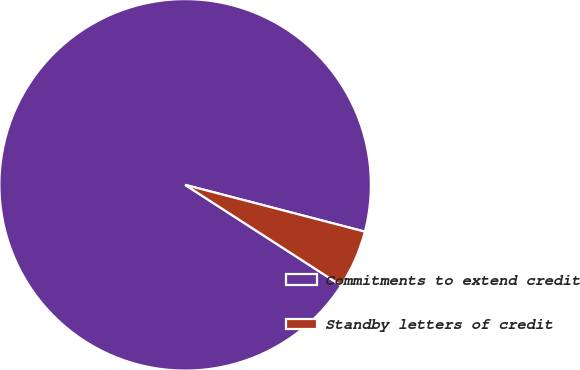Convert chart to OTSL. <chart><loc_0><loc_0><loc_500><loc_500><pie_chart><fcel>Commitments to extend credit<fcel>Standby letters of credit<nl><fcel>94.93%<fcel>5.07%<nl></chart> 